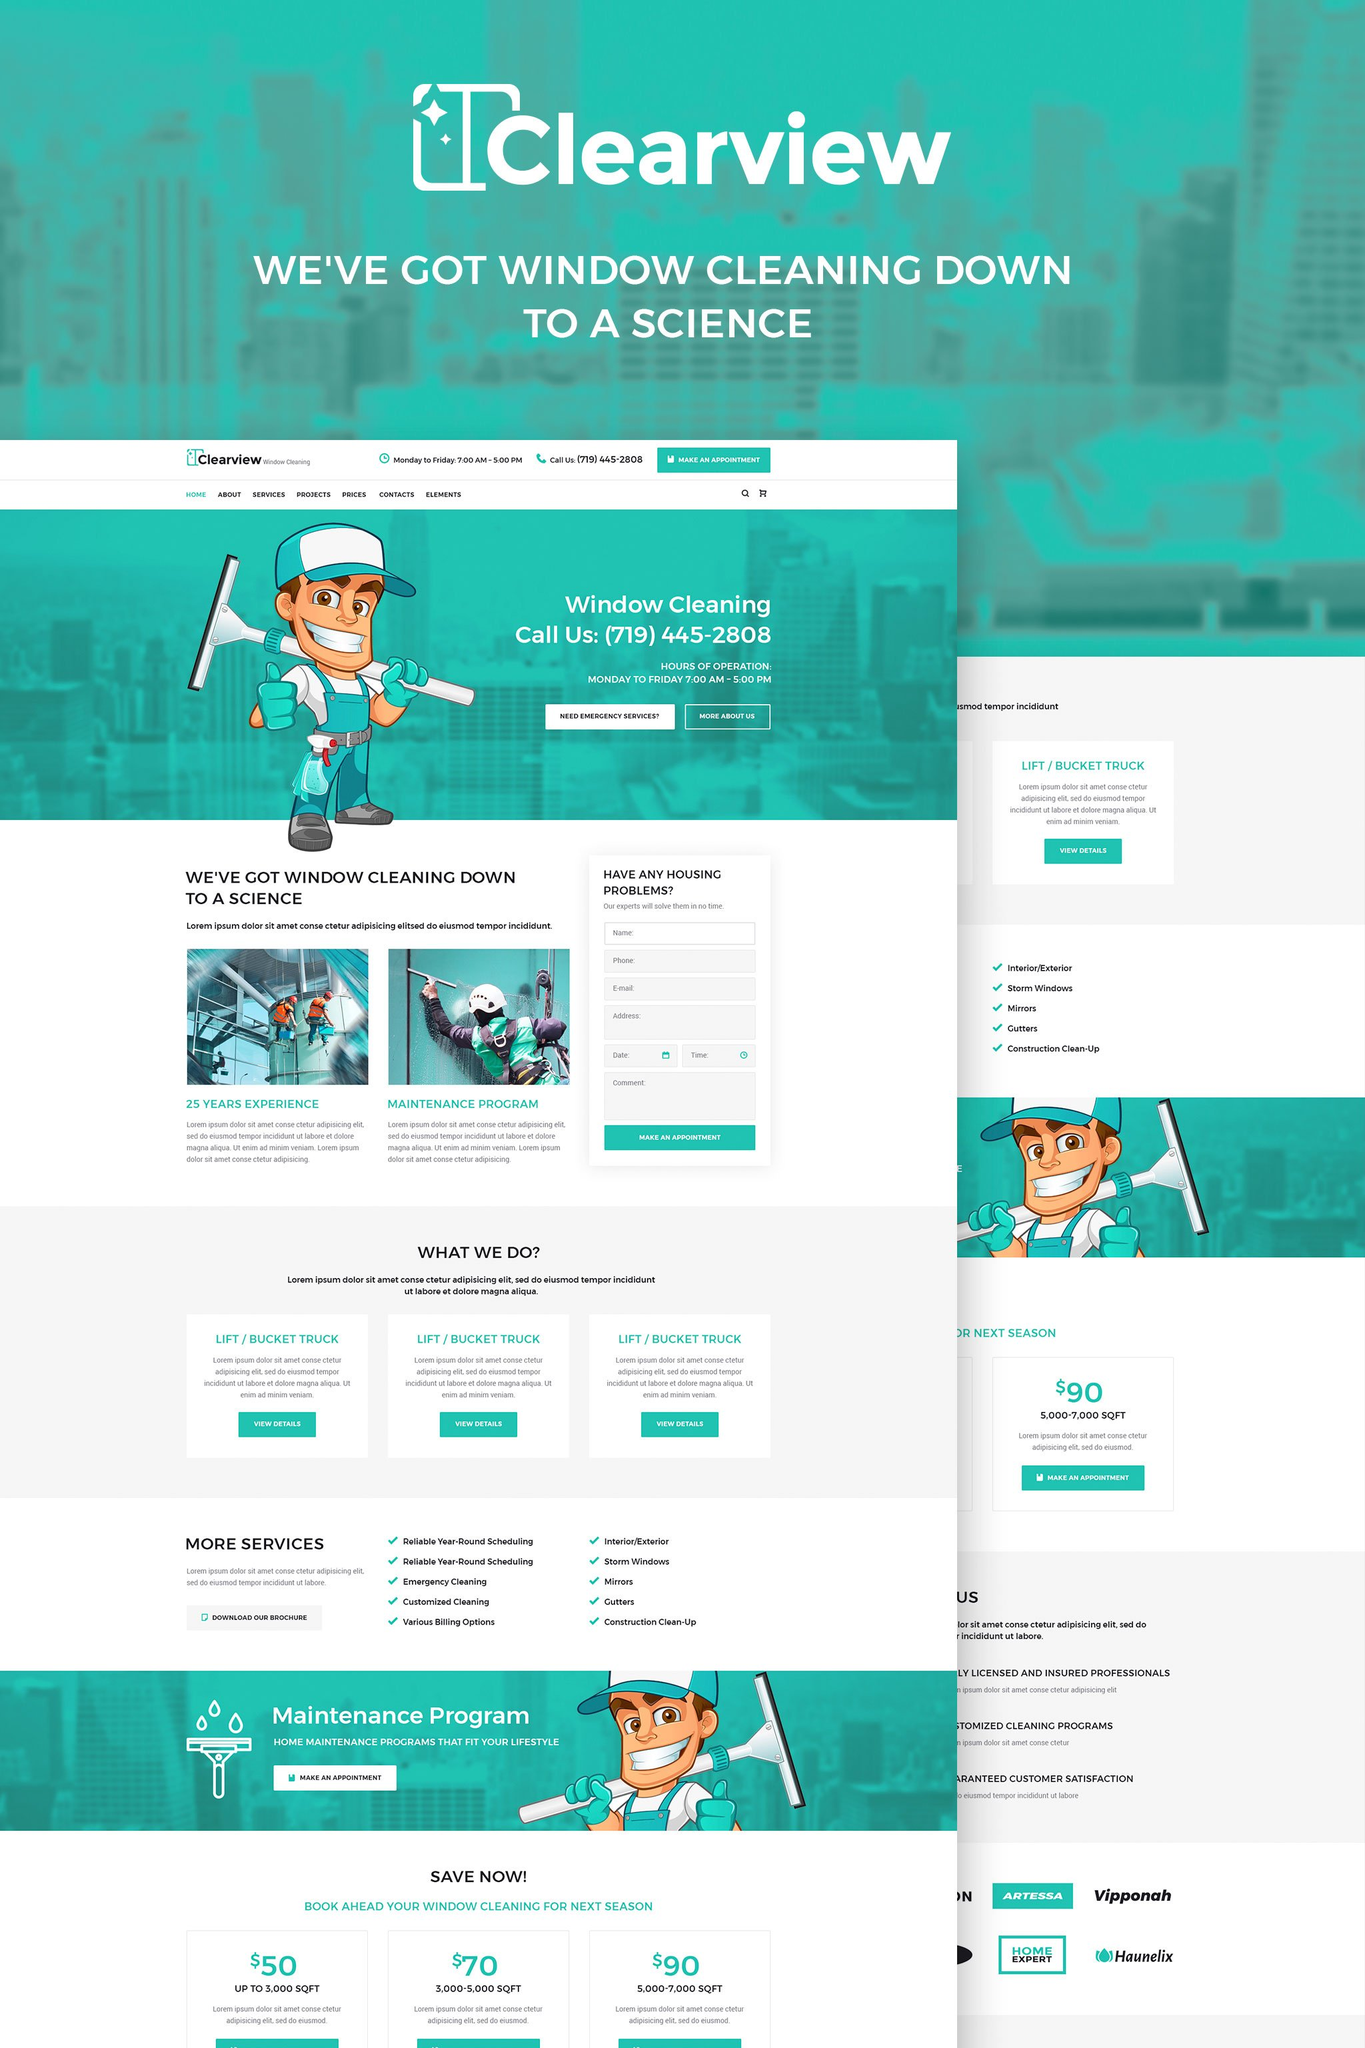What certifications do Clearview professionals have, as indicated on the webpage? The webpage displays a badge indicating that Clearview is a fully licensed and insured business. This suggests that their professionals adhere to industry-standard qualifications and regulatory compliance, essential for building trust and ensuring quality service. 